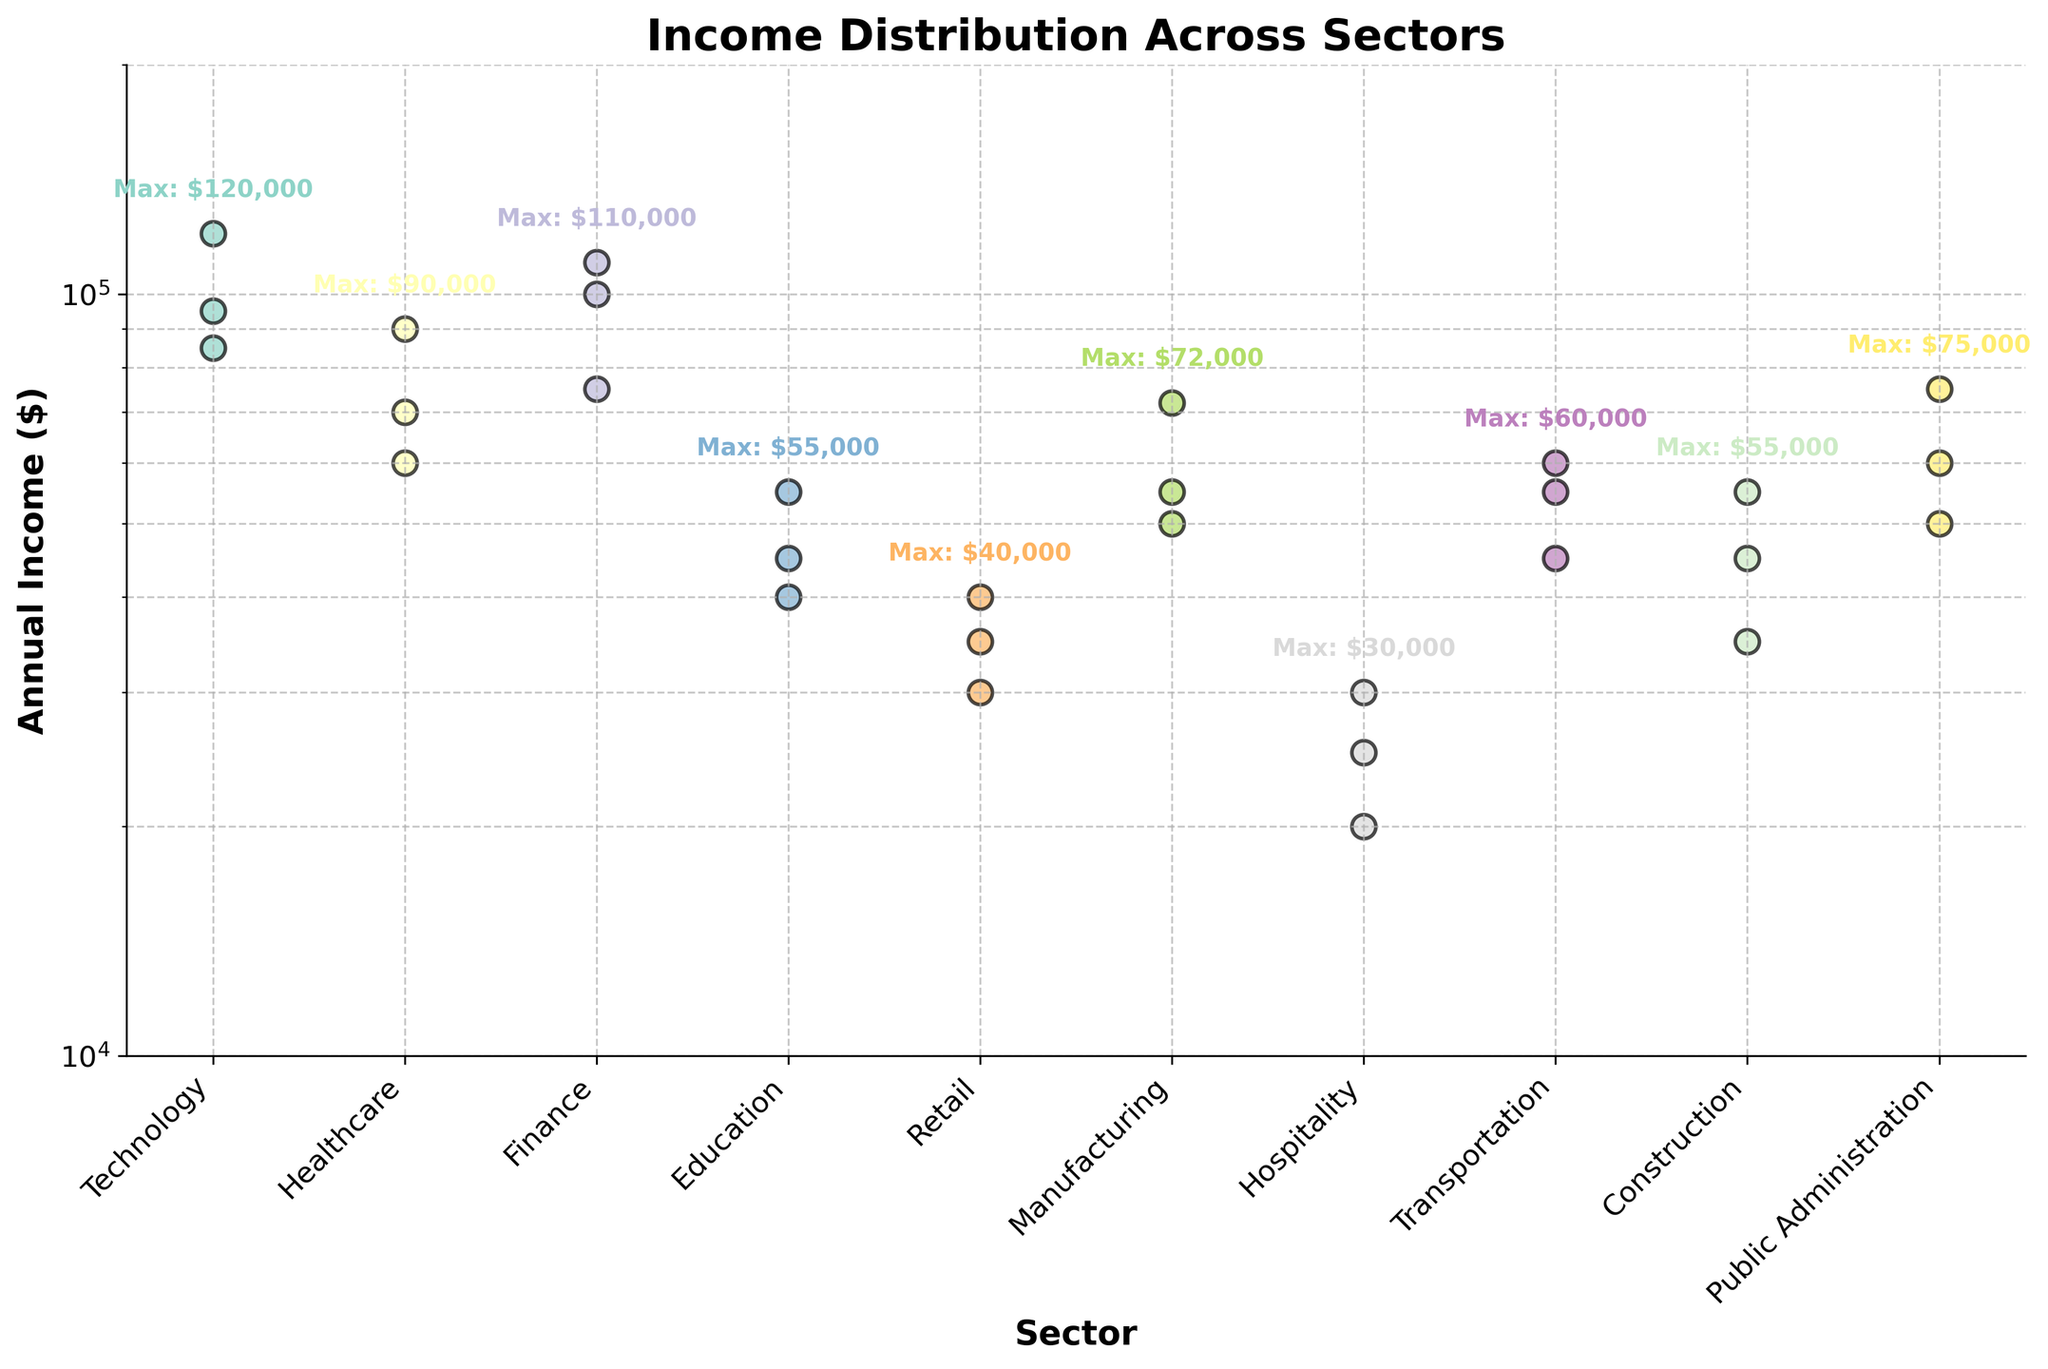What's the title of the figure? The title of the figure is displayed at the top of the plot in bold.
Answer: Income Distribution Across Sectors What is the highest annual income recorded in the Technology sector? Locate the Technology sector points on the scatter plot, and identify the highest positioned point on the y-axis (log scale).
Answer: $120,000 Which sector has the lowest maximum annual income? Compare the maximum annual income for each sector, noted by the text annotation "Max: $" next to each sector. The Hospitality sector has the lowest maximum annual income of $30,000.
Answer: Hospitality What is the range of annual incomes in the Finance sector? The range is the difference between the maximum and minimum annual incomes for the Finance sector, finding the points at the highest and lowest positions. The highest is $110,000, and the lowest is $75,000. Calculate $110,000 - $75,000.
Answer: $35,000 How many sectors have at least one annual income above $100,000? Identify sectors with at least one point above $100,000 on the y-axis. These sectors are Technology (3 points) and Finance (2 points). Staff from other sectors do not earn more than $100,000.
Answer: 2 What’s the average (mean) of the maximum annual incomes across all sectors? List the maximum annual income for each sector: Technology ($120,000), Healthcare ($90,000), Finance ($110,000), Education ($55,000), Retail ($40,000), Manufacturing ($72,000), Hospitality ($30,000), Transportation ($60,000), Construction ($55,000), Public Administration ($75,000). Sum these values and divide by the number of sectors (10). (120000 + 90000 + 110000 + 55000 + 40000 + 72000 + 30000 + 60000 + 55000 + 75000) / 10
Answer: $72,200 Which sector has the widest spread in annual incomes? Calculate the range for each sector by subtracting the smallest annual income from the largest. Identify the sector with the largest spread. Technology has the highest spread from $85,000 to $120,000, giving a range of $35,000. No other sector exceeds this spread.
Answer: Technology Is there any sector with more than one maximum annual income recorded? Check for sectors where the annotation "Max: $" occurs at the same value more than once. Note that all sectors have distinct max values.
Answer: No What is the smallest non-zero tick value on the y-axis? Examine the y-axis of the plot, which is in log scale and find the smallest non-zero tick value starting from 10,000 upwards. This value is a log-based scale.
Answer: 10,000 